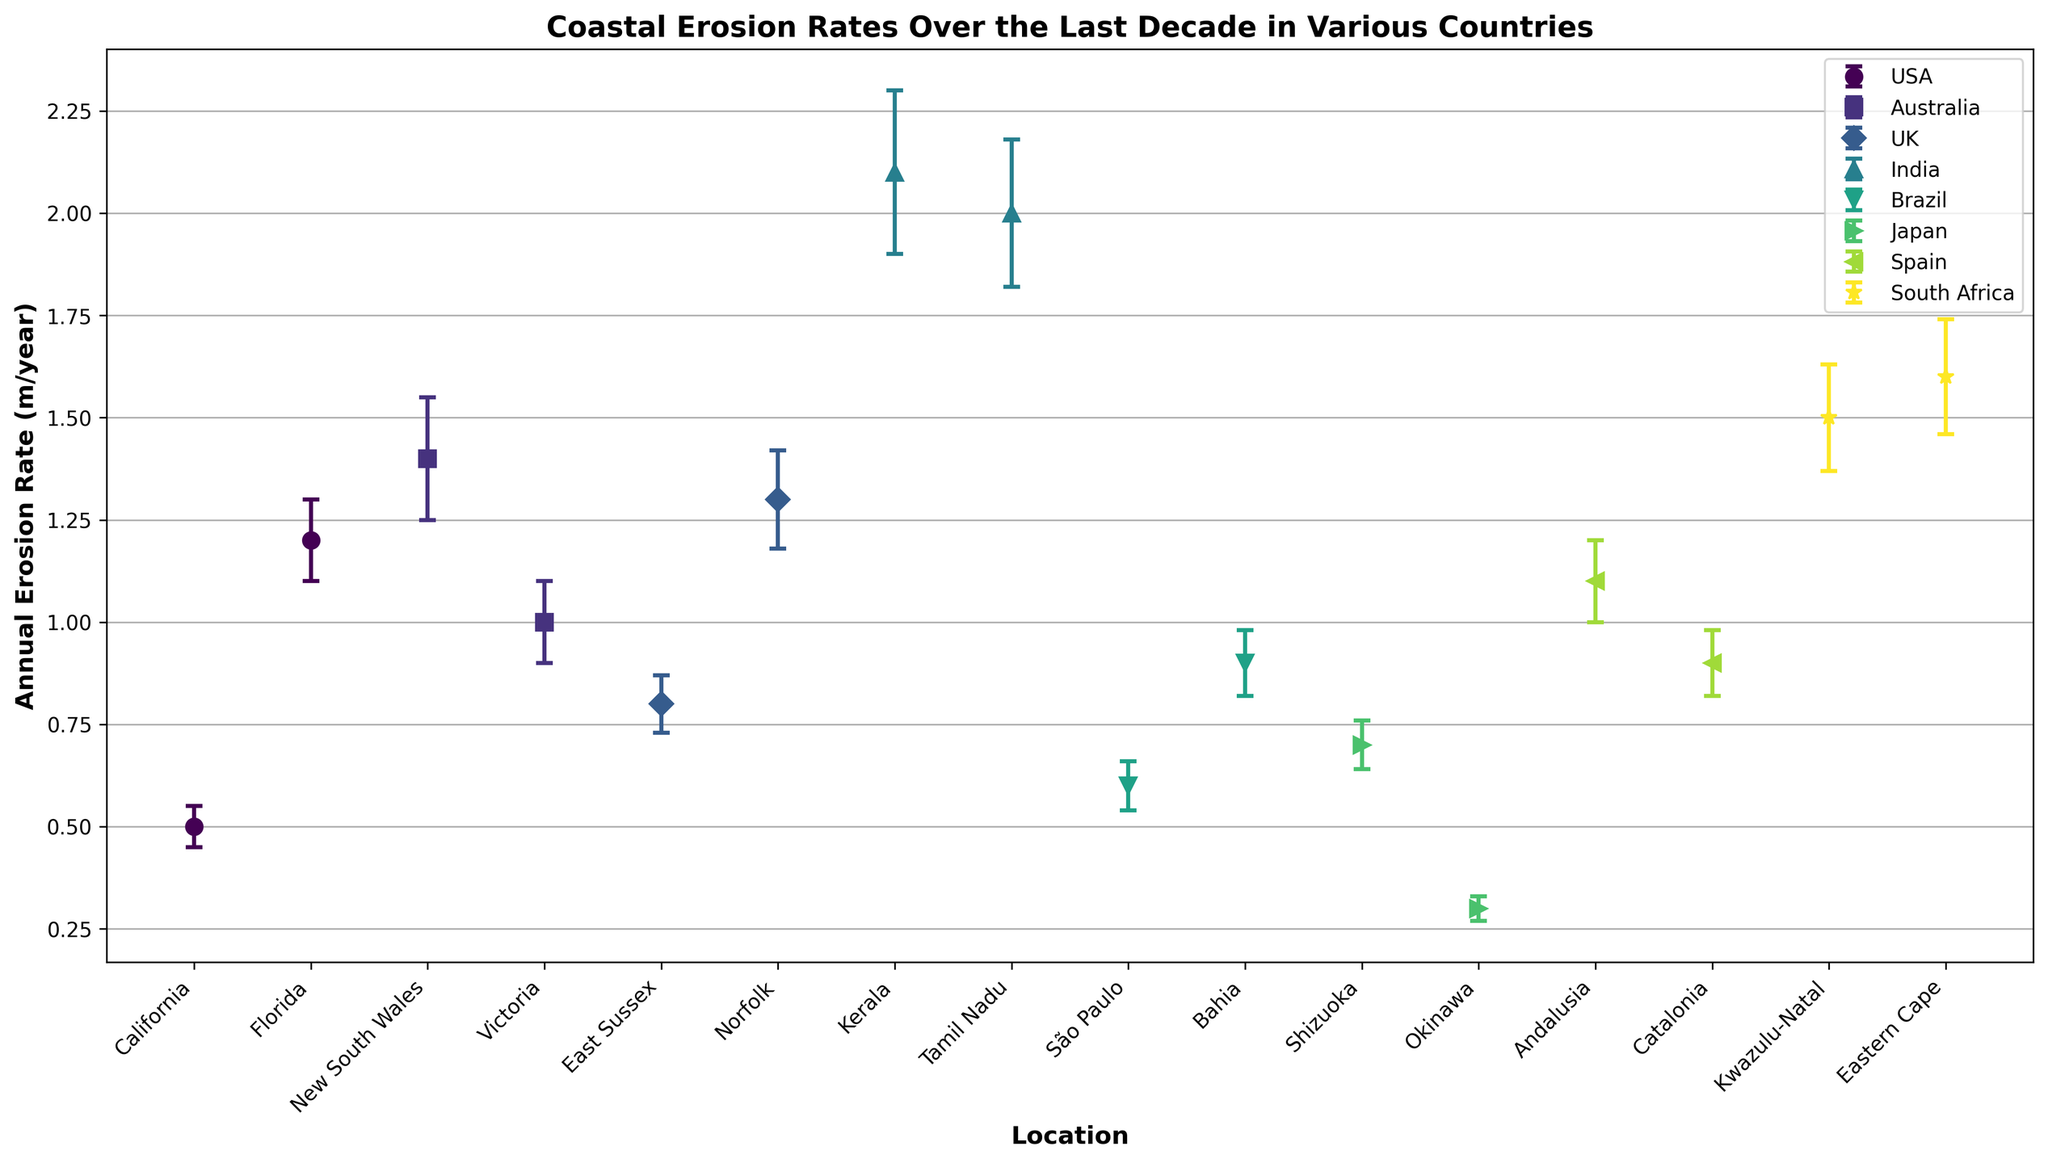Which location in India has the higher annual erosion rate? Observe the two locations in India (Kerala and Tamil Nadu). Kerala has an annual erosion rate of 2.1 m/year, while Tamil Nadu has 2.0 m/year.
Answer: Kerala What is the average annual erosion rate for the locations in the USA? Identify the erosion rates for California and Florida, which are 0.5 m/year and 1.2 m/year. Average them: (0.5 + 1.2) / 2 = 0.85 m/year.
Answer: 0.85 Which country has the location with the highest error estimate? Compare the error estimates for each location in all countries. Kerala, India, has the highest error estimate at 0.2 m/year.
Answer: India Is the annual erosion rate in Victoria, Australia, higher or lower than New South Wales, Australia? Compare the erosion rates between Victoria (1.0 m/year) and New South Wales (1.4 m/year). Victoria is lower.
Answer: Lower What is the difference in annual erosion rates between East Sussex and Norfolk in the UK? Subtract East Sussex’s rate (0.8 m/year) from Norfolk’s rate (1.3 m/year): 1.3 - 0.8 = 0.5 m/year.
Answer: 0.5 Which location in South Africa has a higher annual erosion rate, Kwazulu-Natal or Eastern Cape? Compare the erosion rates for Kwazulu-Natal (1.5 m/year) and Eastern Cape (1.6 m/year). Eastern Cape is higher.
Answer: Eastern Cape Among the locations in Brazil, which has a lower annual erosion rate? Compare the erosion rates in São Paulo (0.6 m/year) and Bahia (0.9 m/year). São Paulo is lower.
Answer: São Paulo What is the total error estimate if you sum up the error estimates for the two locations in Japan? Add the error estimates for Shizuoka (0.06 m/year) and Okinawa (0.03 m/year): 0.06 + 0.03 = 0.09 m/year.
Answer: 0.09 Which country has more locations listed in the figure, Spain or Australia? Spain has Andalusia and Catalonia; Australia has New South Wales and Victoria. Both have 2 locations.
Answer: Equal What is the approximate annual erosion rate range (highest to lowest) of the locations in the figure? Identify the highest rate (Kerala, 2.1 m/year) and the lowest rate (Okinawa, 0.3 m/year). The range is 2.1 - 0.3 = 1.8 m/year.
Answer: 1.8 